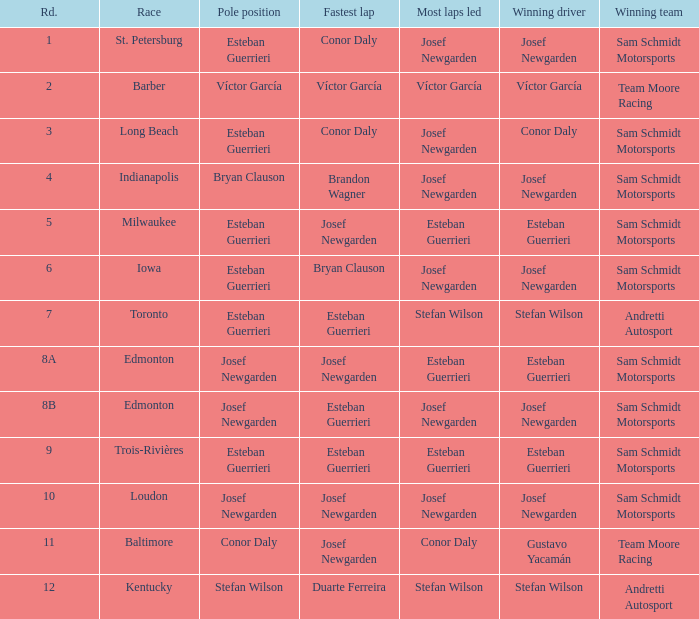Who was the leader for the most laps when brandon wagner achieved the quickest lap? Josef Newgarden. 